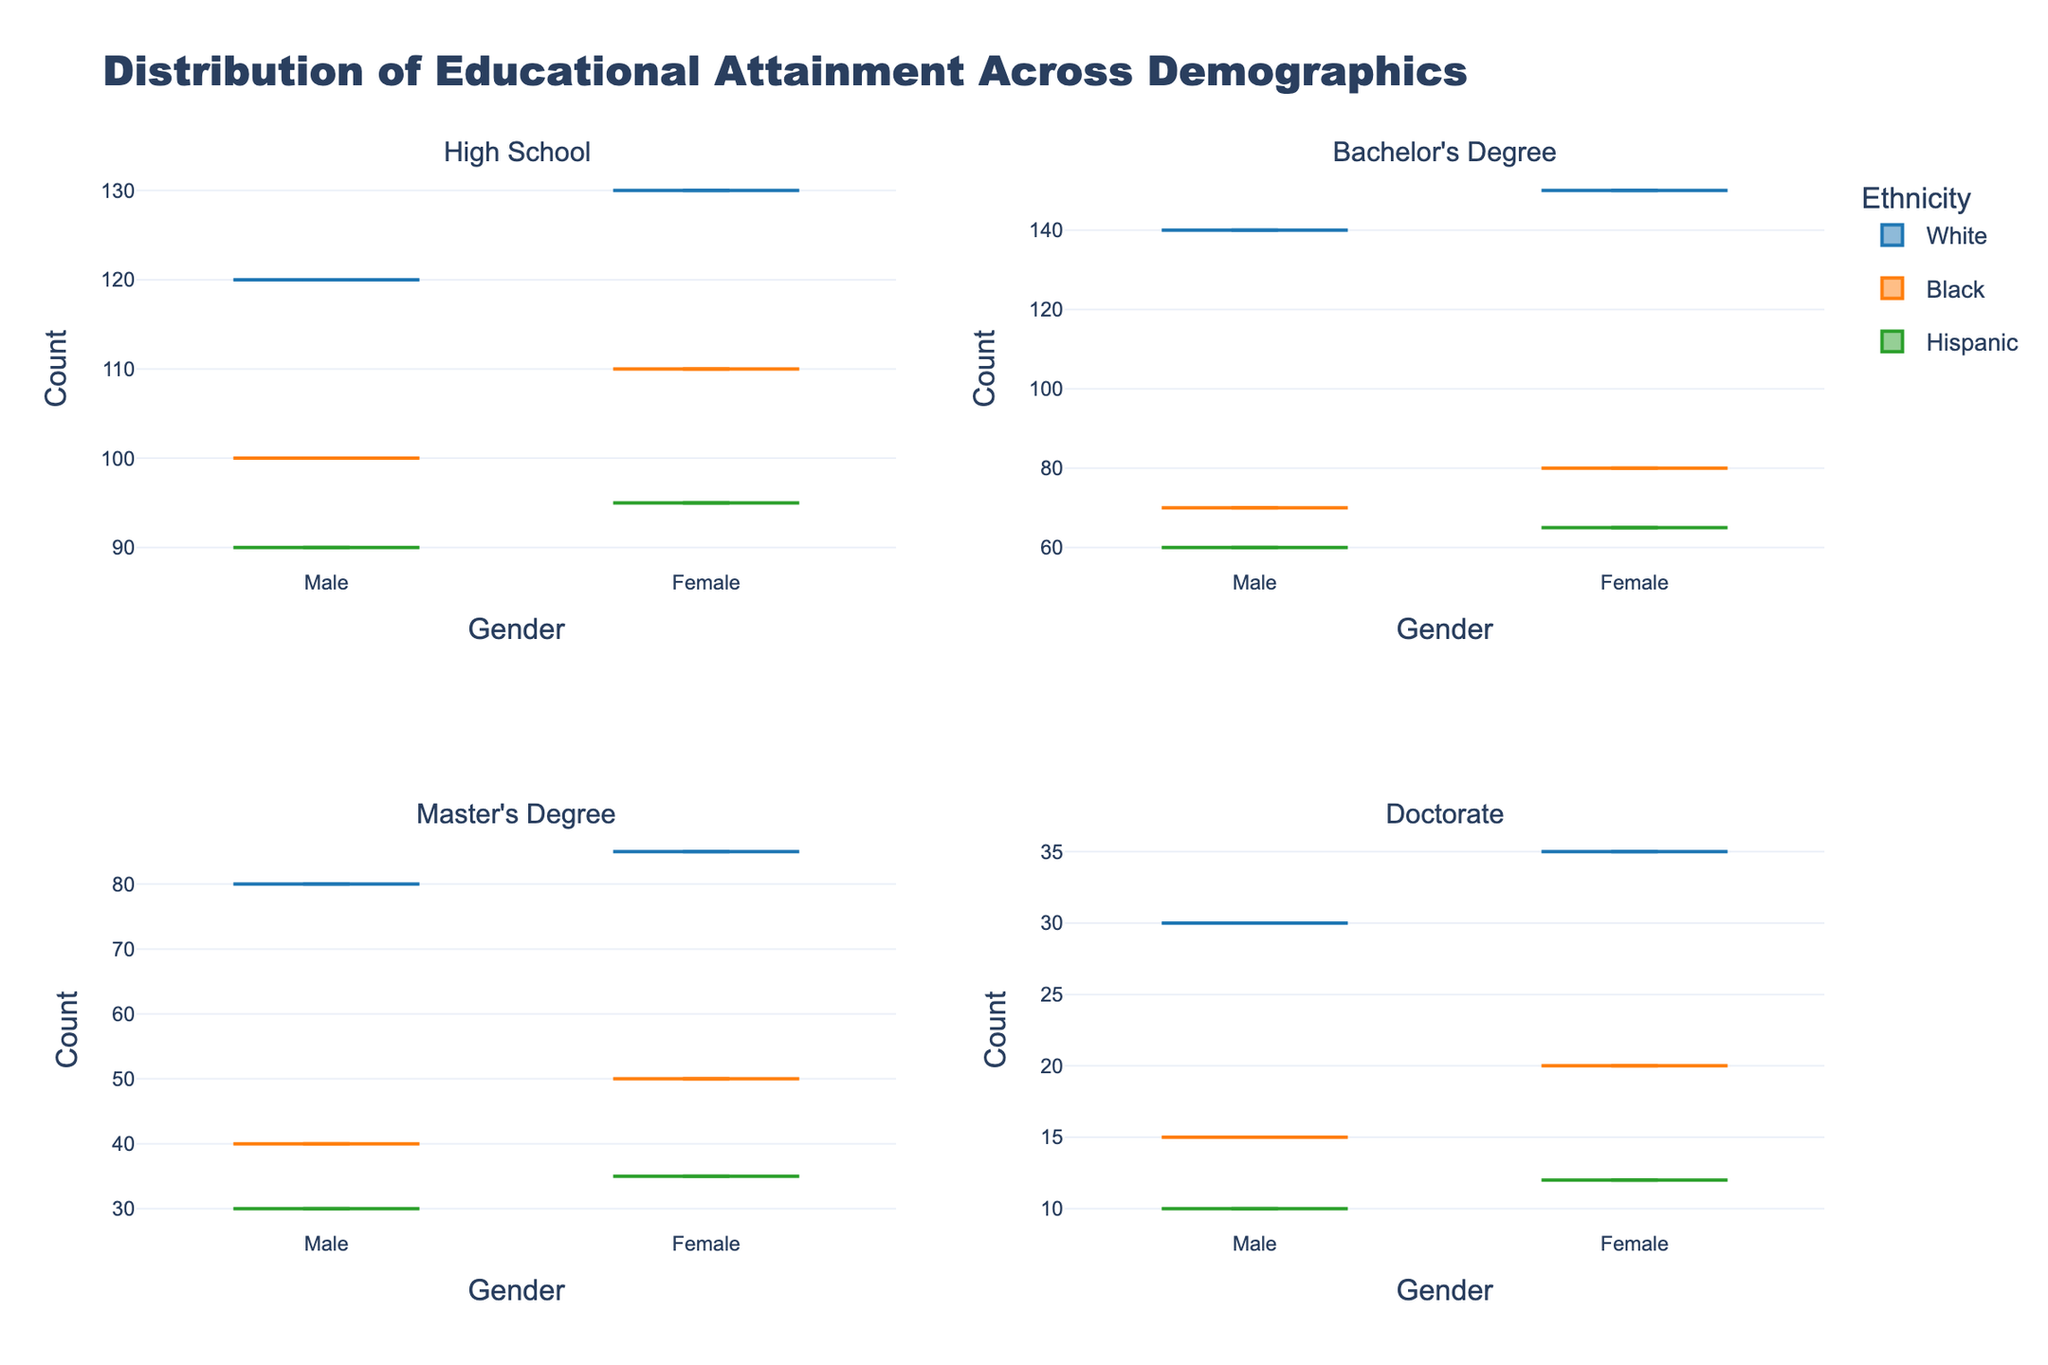Which ethnic group has the highest count in the "High School" educational level? Look at the "High School" subplot and compare the height of the bars for each ethnic group. The tallest bar represents the highest count.
Answer: White Which gender has a higher count for "Bachelor's Degree" in the Black ethnic group? Focus on the "Bachelor's Degree" subplot and compare the bars for Male and Female under the Black ethnic group.
Answer: Female What is the trend in the counts as the educational level increases? Observe all four subplots and note the general pattern in heights of the bars as you move from "High School" to "Doctorate". The counts generally decrease as the educational level increases.
Answer: Decreasing trend Is there a noticeable discrepancy in counts between genders across any educational level? Compare the height of the bars representing Male and Female within each educational level for all ethnic groups. Notice if there are any significant differences in counts between genders.
Answer: Yes Which educational level has the smallest total count across all ethnicities and genders? Add up the counts for both genders across all ethnic groups in each educational level subplot. Identify which educational level has the smallest sum.
Answer: Doctorate How does the count of Hispanic males with a "Master's Degree" compare to the count of Hispanic females with a "Doctorate"? Locate the "Master's Degree" subplot and find the bar for Hispanic males. Compare this with the bar for Hispanic females in the "Doctorate" subplot.
Answer: Higher for Master's Degree Are there any subplots where one ethnic group consistently has higher counts compared to others? Examine each subplot for "High School," "Bachelor's Degree," "Master's Degree," and "Doctorate" and look for an ethnic group that generally stands out with higher counts across these categories.
Answer: White Among the 35-44 age group, which gender has a higher educational attainment in "Master's Degree" for Black ethnicity? Focus on the "Master's Degree" subplot and note the bars for Black ethnicity within 35-44 age group. Compare Male and Female bars.
Answer: Female 